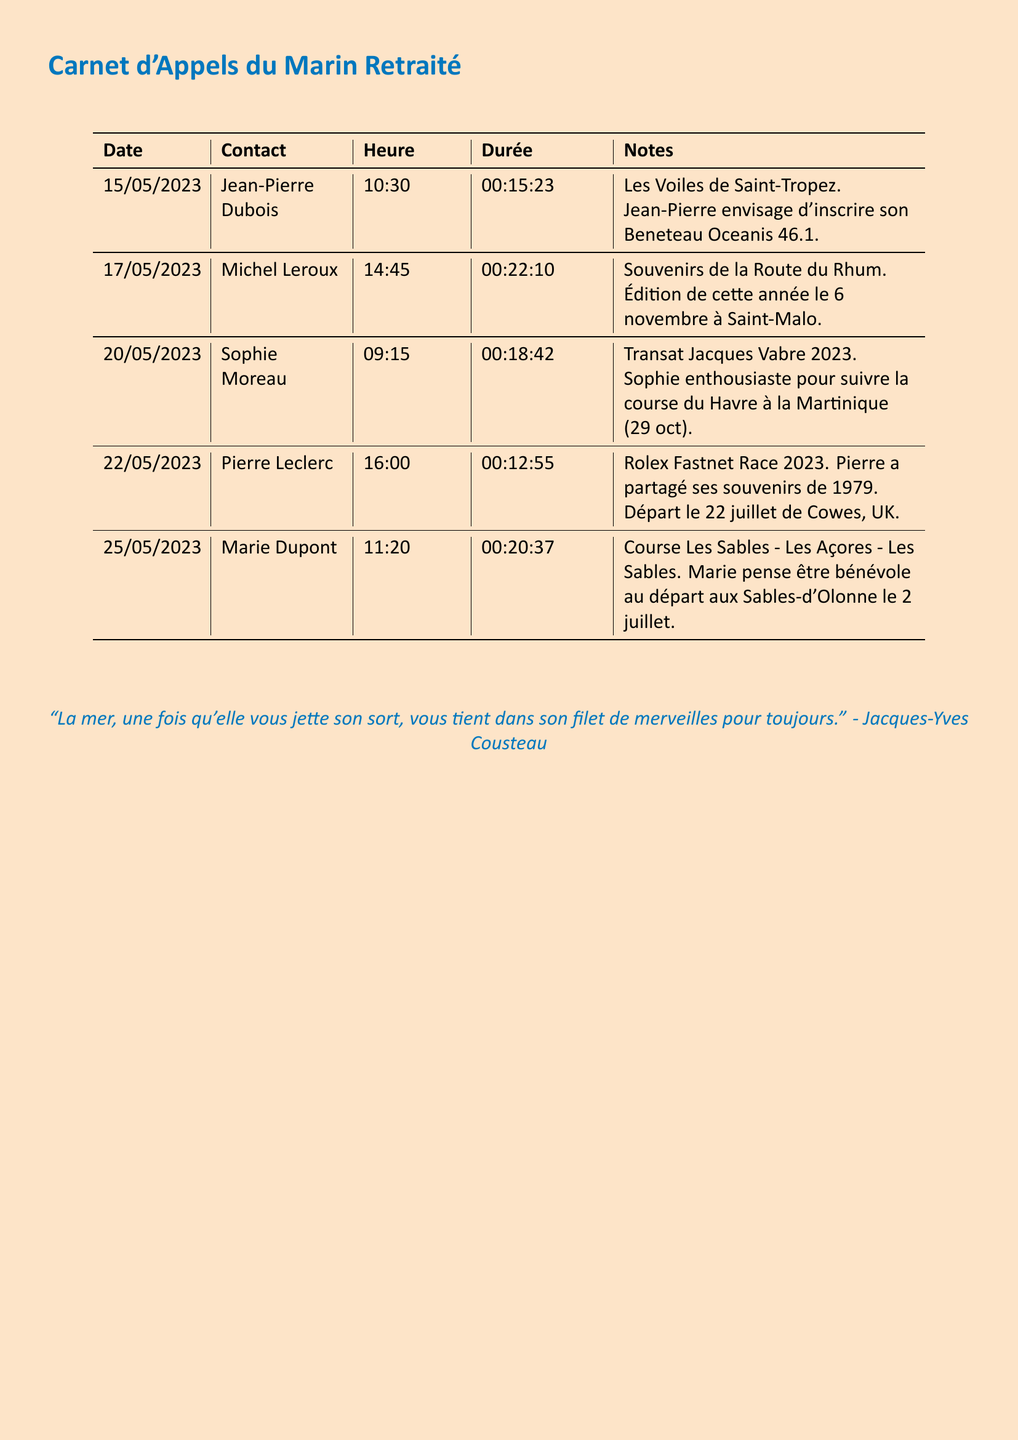What is the date of the call with Jean-Pierre Dubois? The date of the call is found in the first row of the table under the Date column, which is 15/05/2023.
Answer: 15/05/2023 How long was the call with Michel Leroux? The duration of the call is noted in the fourth column for Michel Leroux, which is 00:22:10.
Answer: 00:22:10 What race does Sophie Moreau discuss? Sophie Moreau talks about the Transat Jacques Vabre 2023 in the notes section.
Answer: Transat Jacques Vabre 2023 When does the Rolex Fastnet Race take place? The date of the Rolex Fastnet Race is indicated in the notes for Pierre Leclerc, which states the departure is on 22 July.
Answer: 22 juillet Who is planning to volunteer for the race starting at Les Sables-d'Olonne? The person stated in the notes is Marie Dupont who plans to be a volunteer.
Answer: Marie Dupont How many calls are recorded in this document? The total number of calls can be counted from the table, which shows five calls in total.
Answer: 5 Which sailor shared memories of the Route du Rhum? The sailor who shared those memories is Michel Leroux as noted in his entry.
Answer: Michel Leroux What is the time of the call with Pierre Leclerc? The time is listed next to Pierre Leclerc's name in the third column of the table, which is 16:00.
Answer: 16:00 